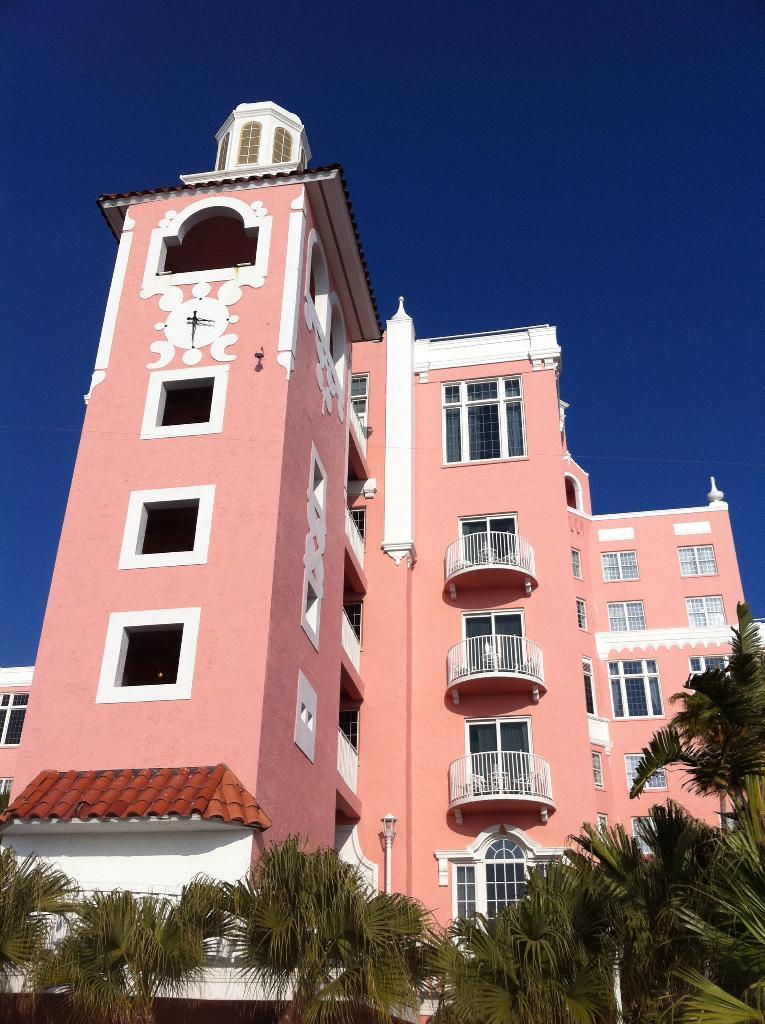What type of natural elements can be seen in the image? There are trees in the image. What type of man-made structures are present in the image? There are buildings in the image. What feature do the buildings have? The buildings have windows. What is the condition of the sky in the image? The sky is clear in the image. What type of neck accessory is being worn by the tree in the image? There are no neck accessories present in the image, as the main subjects are trees and buildings. --- 